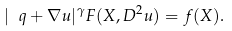<formula> <loc_0><loc_0><loc_500><loc_500>| \ q + \nabla u | ^ { \gamma } F ( X , D ^ { 2 } u ) = f ( X ) .</formula> 